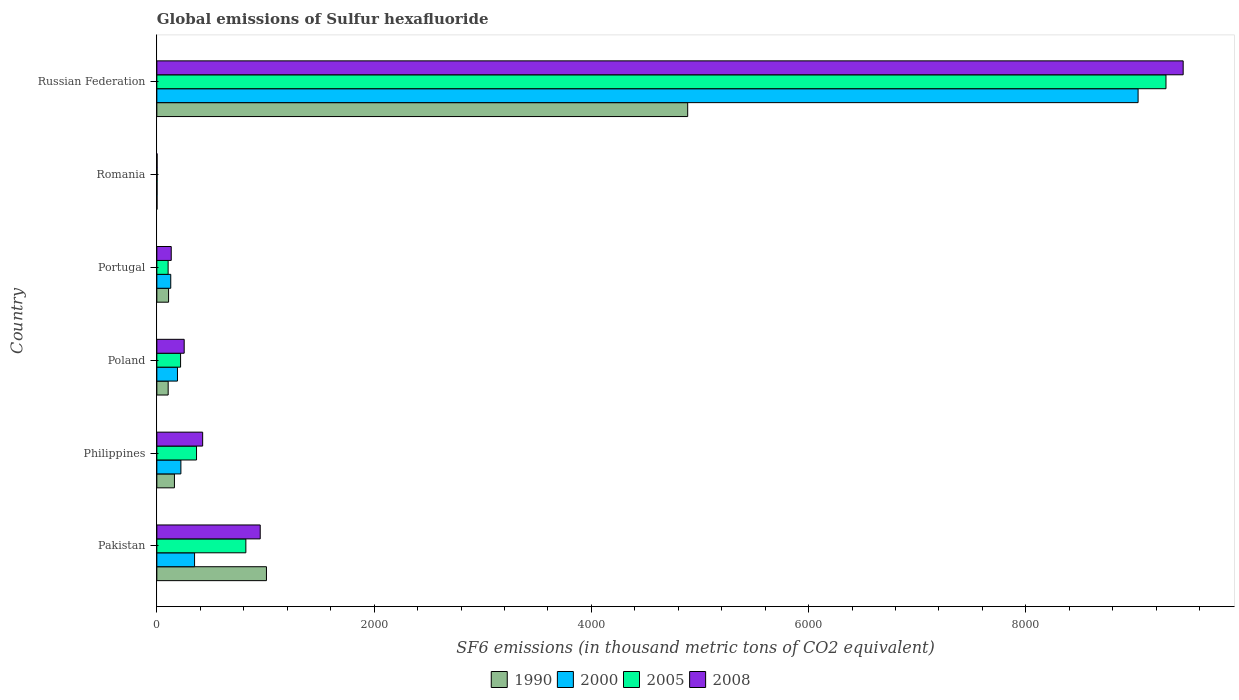How many different coloured bars are there?
Provide a succinct answer. 4. Are the number of bars per tick equal to the number of legend labels?
Your response must be concise. Yes. Are the number of bars on each tick of the Y-axis equal?
Provide a short and direct response. Yes. How many bars are there on the 4th tick from the top?
Your response must be concise. 4. How many bars are there on the 5th tick from the bottom?
Your response must be concise. 4. What is the global emissions of Sulfur hexafluoride in 1990 in Philippines?
Your response must be concise. 161.9. Across all countries, what is the maximum global emissions of Sulfur hexafluoride in 2008?
Ensure brevity in your answer.  9448.2. In which country was the global emissions of Sulfur hexafluoride in 1990 maximum?
Make the answer very short. Russian Federation. In which country was the global emissions of Sulfur hexafluoride in 2000 minimum?
Provide a succinct answer. Romania. What is the total global emissions of Sulfur hexafluoride in 2008 in the graph?
Your answer should be compact. 1.12e+04. What is the difference between the global emissions of Sulfur hexafluoride in 2000 in Pakistan and that in Russian Federation?
Your answer should be compact. -8686. What is the difference between the global emissions of Sulfur hexafluoride in 2008 in Russian Federation and the global emissions of Sulfur hexafluoride in 2005 in Pakistan?
Your answer should be very brief. 8628.8. What is the average global emissions of Sulfur hexafluoride in 2008 per country?
Provide a short and direct response. 1867.98. What is the difference between the global emissions of Sulfur hexafluoride in 2005 and global emissions of Sulfur hexafluoride in 2000 in Russian Federation?
Give a very brief answer. 256.7. In how many countries, is the global emissions of Sulfur hexafluoride in 2008 greater than 8000 thousand metric tons?
Make the answer very short. 1. What is the ratio of the global emissions of Sulfur hexafluoride in 1990 in Portugal to that in Russian Federation?
Offer a terse response. 0.02. Is the global emissions of Sulfur hexafluoride in 1990 in Pakistan less than that in Poland?
Provide a succinct answer. No. What is the difference between the highest and the second highest global emissions of Sulfur hexafluoride in 2005?
Provide a succinct answer. 8470.5. What is the difference between the highest and the lowest global emissions of Sulfur hexafluoride in 2008?
Offer a very short reply. 9445.9. Is the sum of the global emissions of Sulfur hexafluoride in 1990 in Philippines and Portugal greater than the maximum global emissions of Sulfur hexafluoride in 2005 across all countries?
Provide a succinct answer. No. Is it the case that in every country, the sum of the global emissions of Sulfur hexafluoride in 1990 and global emissions of Sulfur hexafluoride in 2008 is greater than the sum of global emissions of Sulfur hexafluoride in 2005 and global emissions of Sulfur hexafluoride in 2000?
Your answer should be very brief. No. What does the 2nd bar from the bottom in Pakistan represents?
Keep it short and to the point. 2000. Is it the case that in every country, the sum of the global emissions of Sulfur hexafluoride in 2008 and global emissions of Sulfur hexafluoride in 1990 is greater than the global emissions of Sulfur hexafluoride in 2000?
Make the answer very short. Yes. How many countries are there in the graph?
Ensure brevity in your answer.  6. What is the difference between two consecutive major ticks on the X-axis?
Offer a terse response. 2000. Does the graph contain any zero values?
Offer a very short reply. No. Does the graph contain grids?
Provide a succinct answer. No. Where does the legend appear in the graph?
Offer a terse response. Bottom center. How many legend labels are there?
Make the answer very short. 4. What is the title of the graph?
Keep it short and to the point. Global emissions of Sulfur hexafluoride. Does "1979" appear as one of the legend labels in the graph?
Provide a short and direct response. No. What is the label or title of the X-axis?
Give a very brief answer. SF6 emissions (in thousand metric tons of CO2 equivalent). What is the SF6 emissions (in thousand metric tons of CO2 equivalent) of 1990 in Pakistan?
Offer a terse response. 1009. What is the SF6 emissions (in thousand metric tons of CO2 equivalent) of 2000 in Pakistan?
Your response must be concise. 347.2. What is the SF6 emissions (in thousand metric tons of CO2 equivalent) in 2005 in Pakistan?
Offer a very short reply. 819.4. What is the SF6 emissions (in thousand metric tons of CO2 equivalent) in 2008 in Pakistan?
Your answer should be compact. 951.6. What is the SF6 emissions (in thousand metric tons of CO2 equivalent) of 1990 in Philippines?
Your answer should be very brief. 161.9. What is the SF6 emissions (in thousand metric tons of CO2 equivalent) of 2000 in Philippines?
Provide a short and direct response. 221.4. What is the SF6 emissions (in thousand metric tons of CO2 equivalent) in 2005 in Philippines?
Keep it short and to the point. 365.3. What is the SF6 emissions (in thousand metric tons of CO2 equivalent) of 2008 in Philippines?
Offer a terse response. 421.7. What is the SF6 emissions (in thousand metric tons of CO2 equivalent) of 1990 in Poland?
Provide a short and direct response. 104.3. What is the SF6 emissions (in thousand metric tons of CO2 equivalent) of 2000 in Poland?
Provide a short and direct response. 189.8. What is the SF6 emissions (in thousand metric tons of CO2 equivalent) of 2005 in Poland?
Ensure brevity in your answer.  218.5. What is the SF6 emissions (in thousand metric tons of CO2 equivalent) in 2008 in Poland?
Offer a terse response. 251.7. What is the SF6 emissions (in thousand metric tons of CO2 equivalent) in 1990 in Portugal?
Keep it short and to the point. 108. What is the SF6 emissions (in thousand metric tons of CO2 equivalent) of 2000 in Portugal?
Provide a succinct answer. 128. What is the SF6 emissions (in thousand metric tons of CO2 equivalent) in 2005 in Portugal?
Provide a short and direct response. 103.8. What is the SF6 emissions (in thousand metric tons of CO2 equivalent) of 2008 in Portugal?
Provide a short and direct response. 132.4. What is the SF6 emissions (in thousand metric tons of CO2 equivalent) in 1990 in Romania?
Give a very brief answer. 1.6. What is the SF6 emissions (in thousand metric tons of CO2 equivalent) in 2008 in Romania?
Offer a very short reply. 2.3. What is the SF6 emissions (in thousand metric tons of CO2 equivalent) in 1990 in Russian Federation?
Offer a very short reply. 4886.8. What is the SF6 emissions (in thousand metric tons of CO2 equivalent) of 2000 in Russian Federation?
Your answer should be very brief. 9033.2. What is the SF6 emissions (in thousand metric tons of CO2 equivalent) of 2005 in Russian Federation?
Make the answer very short. 9289.9. What is the SF6 emissions (in thousand metric tons of CO2 equivalent) of 2008 in Russian Federation?
Give a very brief answer. 9448.2. Across all countries, what is the maximum SF6 emissions (in thousand metric tons of CO2 equivalent) of 1990?
Your answer should be very brief. 4886.8. Across all countries, what is the maximum SF6 emissions (in thousand metric tons of CO2 equivalent) of 2000?
Your answer should be compact. 9033.2. Across all countries, what is the maximum SF6 emissions (in thousand metric tons of CO2 equivalent) of 2005?
Give a very brief answer. 9289.9. Across all countries, what is the maximum SF6 emissions (in thousand metric tons of CO2 equivalent) of 2008?
Keep it short and to the point. 9448.2. Across all countries, what is the minimum SF6 emissions (in thousand metric tons of CO2 equivalent) of 2000?
Provide a short and direct response. 2. Across all countries, what is the minimum SF6 emissions (in thousand metric tons of CO2 equivalent) in 2008?
Provide a succinct answer. 2.3. What is the total SF6 emissions (in thousand metric tons of CO2 equivalent) of 1990 in the graph?
Your response must be concise. 6271.6. What is the total SF6 emissions (in thousand metric tons of CO2 equivalent) of 2000 in the graph?
Your answer should be very brief. 9921.6. What is the total SF6 emissions (in thousand metric tons of CO2 equivalent) of 2005 in the graph?
Ensure brevity in your answer.  1.08e+04. What is the total SF6 emissions (in thousand metric tons of CO2 equivalent) in 2008 in the graph?
Offer a terse response. 1.12e+04. What is the difference between the SF6 emissions (in thousand metric tons of CO2 equivalent) in 1990 in Pakistan and that in Philippines?
Provide a short and direct response. 847.1. What is the difference between the SF6 emissions (in thousand metric tons of CO2 equivalent) in 2000 in Pakistan and that in Philippines?
Your response must be concise. 125.8. What is the difference between the SF6 emissions (in thousand metric tons of CO2 equivalent) of 2005 in Pakistan and that in Philippines?
Your response must be concise. 454.1. What is the difference between the SF6 emissions (in thousand metric tons of CO2 equivalent) in 2008 in Pakistan and that in Philippines?
Give a very brief answer. 529.9. What is the difference between the SF6 emissions (in thousand metric tons of CO2 equivalent) in 1990 in Pakistan and that in Poland?
Your response must be concise. 904.7. What is the difference between the SF6 emissions (in thousand metric tons of CO2 equivalent) of 2000 in Pakistan and that in Poland?
Make the answer very short. 157.4. What is the difference between the SF6 emissions (in thousand metric tons of CO2 equivalent) in 2005 in Pakistan and that in Poland?
Make the answer very short. 600.9. What is the difference between the SF6 emissions (in thousand metric tons of CO2 equivalent) in 2008 in Pakistan and that in Poland?
Keep it short and to the point. 699.9. What is the difference between the SF6 emissions (in thousand metric tons of CO2 equivalent) in 1990 in Pakistan and that in Portugal?
Provide a succinct answer. 901. What is the difference between the SF6 emissions (in thousand metric tons of CO2 equivalent) in 2000 in Pakistan and that in Portugal?
Ensure brevity in your answer.  219.2. What is the difference between the SF6 emissions (in thousand metric tons of CO2 equivalent) of 2005 in Pakistan and that in Portugal?
Offer a terse response. 715.6. What is the difference between the SF6 emissions (in thousand metric tons of CO2 equivalent) in 2008 in Pakistan and that in Portugal?
Give a very brief answer. 819.2. What is the difference between the SF6 emissions (in thousand metric tons of CO2 equivalent) in 1990 in Pakistan and that in Romania?
Offer a terse response. 1007.4. What is the difference between the SF6 emissions (in thousand metric tons of CO2 equivalent) in 2000 in Pakistan and that in Romania?
Offer a very short reply. 345.2. What is the difference between the SF6 emissions (in thousand metric tons of CO2 equivalent) in 2005 in Pakistan and that in Romania?
Ensure brevity in your answer.  817.2. What is the difference between the SF6 emissions (in thousand metric tons of CO2 equivalent) of 2008 in Pakistan and that in Romania?
Offer a terse response. 949.3. What is the difference between the SF6 emissions (in thousand metric tons of CO2 equivalent) in 1990 in Pakistan and that in Russian Federation?
Keep it short and to the point. -3877.8. What is the difference between the SF6 emissions (in thousand metric tons of CO2 equivalent) of 2000 in Pakistan and that in Russian Federation?
Give a very brief answer. -8686. What is the difference between the SF6 emissions (in thousand metric tons of CO2 equivalent) of 2005 in Pakistan and that in Russian Federation?
Offer a very short reply. -8470.5. What is the difference between the SF6 emissions (in thousand metric tons of CO2 equivalent) of 2008 in Pakistan and that in Russian Federation?
Your answer should be very brief. -8496.6. What is the difference between the SF6 emissions (in thousand metric tons of CO2 equivalent) of 1990 in Philippines and that in Poland?
Provide a short and direct response. 57.6. What is the difference between the SF6 emissions (in thousand metric tons of CO2 equivalent) of 2000 in Philippines and that in Poland?
Give a very brief answer. 31.6. What is the difference between the SF6 emissions (in thousand metric tons of CO2 equivalent) in 2005 in Philippines and that in Poland?
Your response must be concise. 146.8. What is the difference between the SF6 emissions (in thousand metric tons of CO2 equivalent) of 2008 in Philippines and that in Poland?
Ensure brevity in your answer.  170. What is the difference between the SF6 emissions (in thousand metric tons of CO2 equivalent) of 1990 in Philippines and that in Portugal?
Ensure brevity in your answer.  53.9. What is the difference between the SF6 emissions (in thousand metric tons of CO2 equivalent) in 2000 in Philippines and that in Portugal?
Your answer should be very brief. 93.4. What is the difference between the SF6 emissions (in thousand metric tons of CO2 equivalent) in 2005 in Philippines and that in Portugal?
Provide a succinct answer. 261.5. What is the difference between the SF6 emissions (in thousand metric tons of CO2 equivalent) of 2008 in Philippines and that in Portugal?
Offer a terse response. 289.3. What is the difference between the SF6 emissions (in thousand metric tons of CO2 equivalent) in 1990 in Philippines and that in Romania?
Your answer should be compact. 160.3. What is the difference between the SF6 emissions (in thousand metric tons of CO2 equivalent) in 2000 in Philippines and that in Romania?
Provide a succinct answer. 219.4. What is the difference between the SF6 emissions (in thousand metric tons of CO2 equivalent) in 2005 in Philippines and that in Romania?
Provide a short and direct response. 363.1. What is the difference between the SF6 emissions (in thousand metric tons of CO2 equivalent) of 2008 in Philippines and that in Romania?
Your response must be concise. 419.4. What is the difference between the SF6 emissions (in thousand metric tons of CO2 equivalent) in 1990 in Philippines and that in Russian Federation?
Your answer should be compact. -4724.9. What is the difference between the SF6 emissions (in thousand metric tons of CO2 equivalent) of 2000 in Philippines and that in Russian Federation?
Your response must be concise. -8811.8. What is the difference between the SF6 emissions (in thousand metric tons of CO2 equivalent) in 2005 in Philippines and that in Russian Federation?
Make the answer very short. -8924.6. What is the difference between the SF6 emissions (in thousand metric tons of CO2 equivalent) of 2008 in Philippines and that in Russian Federation?
Keep it short and to the point. -9026.5. What is the difference between the SF6 emissions (in thousand metric tons of CO2 equivalent) of 1990 in Poland and that in Portugal?
Your response must be concise. -3.7. What is the difference between the SF6 emissions (in thousand metric tons of CO2 equivalent) in 2000 in Poland and that in Portugal?
Offer a very short reply. 61.8. What is the difference between the SF6 emissions (in thousand metric tons of CO2 equivalent) of 2005 in Poland and that in Portugal?
Make the answer very short. 114.7. What is the difference between the SF6 emissions (in thousand metric tons of CO2 equivalent) in 2008 in Poland and that in Portugal?
Ensure brevity in your answer.  119.3. What is the difference between the SF6 emissions (in thousand metric tons of CO2 equivalent) of 1990 in Poland and that in Romania?
Keep it short and to the point. 102.7. What is the difference between the SF6 emissions (in thousand metric tons of CO2 equivalent) of 2000 in Poland and that in Romania?
Your response must be concise. 187.8. What is the difference between the SF6 emissions (in thousand metric tons of CO2 equivalent) in 2005 in Poland and that in Romania?
Provide a short and direct response. 216.3. What is the difference between the SF6 emissions (in thousand metric tons of CO2 equivalent) of 2008 in Poland and that in Romania?
Your response must be concise. 249.4. What is the difference between the SF6 emissions (in thousand metric tons of CO2 equivalent) in 1990 in Poland and that in Russian Federation?
Ensure brevity in your answer.  -4782.5. What is the difference between the SF6 emissions (in thousand metric tons of CO2 equivalent) of 2000 in Poland and that in Russian Federation?
Keep it short and to the point. -8843.4. What is the difference between the SF6 emissions (in thousand metric tons of CO2 equivalent) of 2005 in Poland and that in Russian Federation?
Ensure brevity in your answer.  -9071.4. What is the difference between the SF6 emissions (in thousand metric tons of CO2 equivalent) of 2008 in Poland and that in Russian Federation?
Make the answer very short. -9196.5. What is the difference between the SF6 emissions (in thousand metric tons of CO2 equivalent) in 1990 in Portugal and that in Romania?
Provide a short and direct response. 106.4. What is the difference between the SF6 emissions (in thousand metric tons of CO2 equivalent) in 2000 in Portugal and that in Romania?
Offer a terse response. 126. What is the difference between the SF6 emissions (in thousand metric tons of CO2 equivalent) in 2005 in Portugal and that in Romania?
Your answer should be compact. 101.6. What is the difference between the SF6 emissions (in thousand metric tons of CO2 equivalent) of 2008 in Portugal and that in Romania?
Provide a short and direct response. 130.1. What is the difference between the SF6 emissions (in thousand metric tons of CO2 equivalent) in 1990 in Portugal and that in Russian Federation?
Your response must be concise. -4778.8. What is the difference between the SF6 emissions (in thousand metric tons of CO2 equivalent) of 2000 in Portugal and that in Russian Federation?
Make the answer very short. -8905.2. What is the difference between the SF6 emissions (in thousand metric tons of CO2 equivalent) in 2005 in Portugal and that in Russian Federation?
Offer a terse response. -9186.1. What is the difference between the SF6 emissions (in thousand metric tons of CO2 equivalent) in 2008 in Portugal and that in Russian Federation?
Your answer should be very brief. -9315.8. What is the difference between the SF6 emissions (in thousand metric tons of CO2 equivalent) in 1990 in Romania and that in Russian Federation?
Provide a short and direct response. -4885.2. What is the difference between the SF6 emissions (in thousand metric tons of CO2 equivalent) in 2000 in Romania and that in Russian Federation?
Keep it short and to the point. -9031.2. What is the difference between the SF6 emissions (in thousand metric tons of CO2 equivalent) in 2005 in Romania and that in Russian Federation?
Make the answer very short. -9287.7. What is the difference between the SF6 emissions (in thousand metric tons of CO2 equivalent) of 2008 in Romania and that in Russian Federation?
Ensure brevity in your answer.  -9445.9. What is the difference between the SF6 emissions (in thousand metric tons of CO2 equivalent) in 1990 in Pakistan and the SF6 emissions (in thousand metric tons of CO2 equivalent) in 2000 in Philippines?
Offer a very short reply. 787.6. What is the difference between the SF6 emissions (in thousand metric tons of CO2 equivalent) in 1990 in Pakistan and the SF6 emissions (in thousand metric tons of CO2 equivalent) in 2005 in Philippines?
Offer a very short reply. 643.7. What is the difference between the SF6 emissions (in thousand metric tons of CO2 equivalent) of 1990 in Pakistan and the SF6 emissions (in thousand metric tons of CO2 equivalent) of 2008 in Philippines?
Give a very brief answer. 587.3. What is the difference between the SF6 emissions (in thousand metric tons of CO2 equivalent) of 2000 in Pakistan and the SF6 emissions (in thousand metric tons of CO2 equivalent) of 2005 in Philippines?
Provide a succinct answer. -18.1. What is the difference between the SF6 emissions (in thousand metric tons of CO2 equivalent) of 2000 in Pakistan and the SF6 emissions (in thousand metric tons of CO2 equivalent) of 2008 in Philippines?
Provide a short and direct response. -74.5. What is the difference between the SF6 emissions (in thousand metric tons of CO2 equivalent) in 2005 in Pakistan and the SF6 emissions (in thousand metric tons of CO2 equivalent) in 2008 in Philippines?
Offer a very short reply. 397.7. What is the difference between the SF6 emissions (in thousand metric tons of CO2 equivalent) of 1990 in Pakistan and the SF6 emissions (in thousand metric tons of CO2 equivalent) of 2000 in Poland?
Provide a short and direct response. 819.2. What is the difference between the SF6 emissions (in thousand metric tons of CO2 equivalent) in 1990 in Pakistan and the SF6 emissions (in thousand metric tons of CO2 equivalent) in 2005 in Poland?
Give a very brief answer. 790.5. What is the difference between the SF6 emissions (in thousand metric tons of CO2 equivalent) in 1990 in Pakistan and the SF6 emissions (in thousand metric tons of CO2 equivalent) in 2008 in Poland?
Give a very brief answer. 757.3. What is the difference between the SF6 emissions (in thousand metric tons of CO2 equivalent) of 2000 in Pakistan and the SF6 emissions (in thousand metric tons of CO2 equivalent) of 2005 in Poland?
Ensure brevity in your answer.  128.7. What is the difference between the SF6 emissions (in thousand metric tons of CO2 equivalent) in 2000 in Pakistan and the SF6 emissions (in thousand metric tons of CO2 equivalent) in 2008 in Poland?
Keep it short and to the point. 95.5. What is the difference between the SF6 emissions (in thousand metric tons of CO2 equivalent) in 2005 in Pakistan and the SF6 emissions (in thousand metric tons of CO2 equivalent) in 2008 in Poland?
Your answer should be compact. 567.7. What is the difference between the SF6 emissions (in thousand metric tons of CO2 equivalent) of 1990 in Pakistan and the SF6 emissions (in thousand metric tons of CO2 equivalent) of 2000 in Portugal?
Offer a terse response. 881. What is the difference between the SF6 emissions (in thousand metric tons of CO2 equivalent) of 1990 in Pakistan and the SF6 emissions (in thousand metric tons of CO2 equivalent) of 2005 in Portugal?
Provide a succinct answer. 905.2. What is the difference between the SF6 emissions (in thousand metric tons of CO2 equivalent) in 1990 in Pakistan and the SF6 emissions (in thousand metric tons of CO2 equivalent) in 2008 in Portugal?
Your response must be concise. 876.6. What is the difference between the SF6 emissions (in thousand metric tons of CO2 equivalent) in 2000 in Pakistan and the SF6 emissions (in thousand metric tons of CO2 equivalent) in 2005 in Portugal?
Your response must be concise. 243.4. What is the difference between the SF6 emissions (in thousand metric tons of CO2 equivalent) of 2000 in Pakistan and the SF6 emissions (in thousand metric tons of CO2 equivalent) of 2008 in Portugal?
Offer a terse response. 214.8. What is the difference between the SF6 emissions (in thousand metric tons of CO2 equivalent) of 2005 in Pakistan and the SF6 emissions (in thousand metric tons of CO2 equivalent) of 2008 in Portugal?
Offer a terse response. 687. What is the difference between the SF6 emissions (in thousand metric tons of CO2 equivalent) of 1990 in Pakistan and the SF6 emissions (in thousand metric tons of CO2 equivalent) of 2000 in Romania?
Give a very brief answer. 1007. What is the difference between the SF6 emissions (in thousand metric tons of CO2 equivalent) in 1990 in Pakistan and the SF6 emissions (in thousand metric tons of CO2 equivalent) in 2005 in Romania?
Keep it short and to the point. 1006.8. What is the difference between the SF6 emissions (in thousand metric tons of CO2 equivalent) of 1990 in Pakistan and the SF6 emissions (in thousand metric tons of CO2 equivalent) of 2008 in Romania?
Offer a terse response. 1006.7. What is the difference between the SF6 emissions (in thousand metric tons of CO2 equivalent) in 2000 in Pakistan and the SF6 emissions (in thousand metric tons of CO2 equivalent) in 2005 in Romania?
Your response must be concise. 345. What is the difference between the SF6 emissions (in thousand metric tons of CO2 equivalent) of 2000 in Pakistan and the SF6 emissions (in thousand metric tons of CO2 equivalent) of 2008 in Romania?
Provide a short and direct response. 344.9. What is the difference between the SF6 emissions (in thousand metric tons of CO2 equivalent) in 2005 in Pakistan and the SF6 emissions (in thousand metric tons of CO2 equivalent) in 2008 in Romania?
Keep it short and to the point. 817.1. What is the difference between the SF6 emissions (in thousand metric tons of CO2 equivalent) in 1990 in Pakistan and the SF6 emissions (in thousand metric tons of CO2 equivalent) in 2000 in Russian Federation?
Give a very brief answer. -8024.2. What is the difference between the SF6 emissions (in thousand metric tons of CO2 equivalent) in 1990 in Pakistan and the SF6 emissions (in thousand metric tons of CO2 equivalent) in 2005 in Russian Federation?
Give a very brief answer. -8280.9. What is the difference between the SF6 emissions (in thousand metric tons of CO2 equivalent) in 1990 in Pakistan and the SF6 emissions (in thousand metric tons of CO2 equivalent) in 2008 in Russian Federation?
Keep it short and to the point. -8439.2. What is the difference between the SF6 emissions (in thousand metric tons of CO2 equivalent) in 2000 in Pakistan and the SF6 emissions (in thousand metric tons of CO2 equivalent) in 2005 in Russian Federation?
Make the answer very short. -8942.7. What is the difference between the SF6 emissions (in thousand metric tons of CO2 equivalent) of 2000 in Pakistan and the SF6 emissions (in thousand metric tons of CO2 equivalent) of 2008 in Russian Federation?
Provide a succinct answer. -9101. What is the difference between the SF6 emissions (in thousand metric tons of CO2 equivalent) in 2005 in Pakistan and the SF6 emissions (in thousand metric tons of CO2 equivalent) in 2008 in Russian Federation?
Offer a very short reply. -8628.8. What is the difference between the SF6 emissions (in thousand metric tons of CO2 equivalent) of 1990 in Philippines and the SF6 emissions (in thousand metric tons of CO2 equivalent) of 2000 in Poland?
Offer a terse response. -27.9. What is the difference between the SF6 emissions (in thousand metric tons of CO2 equivalent) in 1990 in Philippines and the SF6 emissions (in thousand metric tons of CO2 equivalent) in 2005 in Poland?
Your answer should be very brief. -56.6. What is the difference between the SF6 emissions (in thousand metric tons of CO2 equivalent) in 1990 in Philippines and the SF6 emissions (in thousand metric tons of CO2 equivalent) in 2008 in Poland?
Your response must be concise. -89.8. What is the difference between the SF6 emissions (in thousand metric tons of CO2 equivalent) of 2000 in Philippines and the SF6 emissions (in thousand metric tons of CO2 equivalent) of 2008 in Poland?
Your response must be concise. -30.3. What is the difference between the SF6 emissions (in thousand metric tons of CO2 equivalent) in 2005 in Philippines and the SF6 emissions (in thousand metric tons of CO2 equivalent) in 2008 in Poland?
Ensure brevity in your answer.  113.6. What is the difference between the SF6 emissions (in thousand metric tons of CO2 equivalent) in 1990 in Philippines and the SF6 emissions (in thousand metric tons of CO2 equivalent) in 2000 in Portugal?
Give a very brief answer. 33.9. What is the difference between the SF6 emissions (in thousand metric tons of CO2 equivalent) in 1990 in Philippines and the SF6 emissions (in thousand metric tons of CO2 equivalent) in 2005 in Portugal?
Provide a succinct answer. 58.1. What is the difference between the SF6 emissions (in thousand metric tons of CO2 equivalent) in 1990 in Philippines and the SF6 emissions (in thousand metric tons of CO2 equivalent) in 2008 in Portugal?
Keep it short and to the point. 29.5. What is the difference between the SF6 emissions (in thousand metric tons of CO2 equivalent) of 2000 in Philippines and the SF6 emissions (in thousand metric tons of CO2 equivalent) of 2005 in Portugal?
Your response must be concise. 117.6. What is the difference between the SF6 emissions (in thousand metric tons of CO2 equivalent) in 2000 in Philippines and the SF6 emissions (in thousand metric tons of CO2 equivalent) in 2008 in Portugal?
Make the answer very short. 89. What is the difference between the SF6 emissions (in thousand metric tons of CO2 equivalent) of 2005 in Philippines and the SF6 emissions (in thousand metric tons of CO2 equivalent) of 2008 in Portugal?
Ensure brevity in your answer.  232.9. What is the difference between the SF6 emissions (in thousand metric tons of CO2 equivalent) in 1990 in Philippines and the SF6 emissions (in thousand metric tons of CO2 equivalent) in 2000 in Romania?
Your response must be concise. 159.9. What is the difference between the SF6 emissions (in thousand metric tons of CO2 equivalent) in 1990 in Philippines and the SF6 emissions (in thousand metric tons of CO2 equivalent) in 2005 in Romania?
Provide a succinct answer. 159.7. What is the difference between the SF6 emissions (in thousand metric tons of CO2 equivalent) of 1990 in Philippines and the SF6 emissions (in thousand metric tons of CO2 equivalent) of 2008 in Romania?
Keep it short and to the point. 159.6. What is the difference between the SF6 emissions (in thousand metric tons of CO2 equivalent) in 2000 in Philippines and the SF6 emissions (in thousand metric tons of CO2 equivalent) in 2005 in Romania?
Provide a succinct answer. 219.2. What is the difference between the SF6 emissions (in thousand metric tons of CO2 equivalent) in 2000 in Philippines and the SF6 emissions (in thousand metric tons of CO2 equivalent) in 2008 in Romania?
Your answer should be very brief. 219.1. What is the difference between the SF6 emissions (in thousand metric tons of CO2 equivalent) in 2005 in Philippines and the SF6 emissions (in thousand metric tons of CO2 equivalent) in 2008 in Romania?
Ensure brevity in your answer.  363. What is the difference between the SF6 emissions (in thousand metric tons of CO2 equivalent) of 1990 in Philippines and the SF6 emissions (in thousand metric tons of CO2 equivalent) of 2000 in Russian Federation?
Your answer should be compact. -8871.3. What is the difference between the SF6 emissions (in thousand metric tons of CO2 equivalent) of 1990 in Philippines and the SF6 emissions (in thousand metric tons of CO2 equivalent) of 2005 in Russian Federation?
Provide a short and direct response. -9128. What is the difference between the SF6 emissions (in thousand metric tons of CO2 equivalent) in 1990 in Philippines and the SF6 emissions (in thousand metric tons of CO2 equivalent) in 2008 in Russian Federation?
Provide a short and direct response. -9286.3. What is the difference between the SF6 emissions (in thousand metric tons of CO2 equivalent) in 2000 in Philippines and the SF6 emissions (in thousand metric tons of CO2 equivalent) in 2005 in Russian Federation?
Your answer should be compact. -9068.5. What is the difference between the SF6 emissions (in thousand metric tons of CO2 equivalent) of 2000 in Philippines and the SF6 emissions (in thousand metric tons of CO2 equivalent) of 2008 in Russian Federation?
Your response must be concise. -9226.8. What is the difference between the SF6 emissions (in thousand metric tons of CO2 equivalent) in 2005 in Philippines and the SF6 emissions (in thousand metric tons of CO2 equivalent) in 2008 in Russian Federation?
Your response must be concise. -9082.9. What is the difference between the SF6 emissions (in thousand metric tons of CO2 equivalent) of 1990 in Poland and the SF6 emissions (in thousand metric tons of CO2 equivalent) of 2000 in Portugal?
Ensure brevity in your answer.  -23.7. What is the difference between the SF6 emissions (in thousand metric tons of CO2 equivalent) of 1990 in Poland and the SF6 emissions (in thousand metric tons of CO2 equivalent) of 2005 in Portugal?
Provide a short and direct response. 0.5. What is the difference between the SF6 emissions (in thousand metric tons of CO2 equivalent) in 1990 in Poland and the SF6 emissions (in thousand metric tons of CO2 equivalent) in 2008 in Portugal?
Provide a short and direct response. -28.1. What is the difference between the SF6 emissions (in thousand metric tons of CO2 equivalent) of 2000 in Poland and the SF6 emissions (in thousand metric tons of CO2 equivalent) of 2008 in Portugal?
Offer a terse response. 57.4. What is the difference between the SF6 emissions (in thousand metric tons of CO2 equivalent) in 2005 in Poland and the SF6 emissions (in thousand metric tons of CO2 equivalent) in 2008 in Portugal?
Offer a very short reply. 86.1. What is the difference between the SF6 emissions (in thousand metric tons of CO2 equivalent) in 1990 in Poland and the SF6 emissions (in thousand metric tons of CO2 equivalent) in 2000 in Romania?
Provide a short and direct response. 102.3. What is the difference between the SF6 emissions (in thousand metric tons of CO2 equivalent) of 1990 in Poland and the SF6 emissions (in thousand metric tons of CO2 equivalent) of 2005 in Romania?
Your answer should be compact. 102.1. What is the difference between the SF6 emissions (in thousand metric tons of CO2 equivalent) of 1990 in Poland and the SF6 emissions (in thousand metric tons of CO2 equivalent) of 2008 in Romania?
Keep it short and to the point. 102. What is the difference between the SF6 emissions (in thousand metric tons of CO2 equivalent) in 2000 in Poland and the SF6 emissions (in thousand metric tons of CO2 equivalent) in 2005 in Romania?
Your answer should be very brief. 187.6. What is the difference between the SF6 emissions (in thousand metric tons of CO2 equivalent) in 2000 in Poland and the SF6 emissions (in thousand metric tons of CO2 equivalent) in 2008 in Romania?
Your response must be concise. 187.5. What is the difference between the SF6 emissions (in thousand metric tons of CO2 equivalent) of 2005 in Poland and the SF6 emissions (in thousand metric tons of CO2 equivalent) of 2008 in Romania?
Give a very brief answer. 216.2. What is the difference between the SF6 emissions (in thousand metric tons of CO2 equivalent) in 1990 in Poland and the SF6 emissions (in thousand metric tons of CO2 equivalent) in 2000 in Russian Federation?
Make the answer very short. -8928.9. What is the difference between the SF6 emissions (in thousand metric tons of CO2 equivalent) of 1990 in Poland and the SF6 emissions (in thousand metric tons of CO2 equivalent) of 2005 in Russian Federation?
Provide a short and direct response. -9185.6. What is the difference between the SF6 emissions (in thousand metric tons of CO2 equivalent) in 1990 in Poland and the SF6 emissions (in thousand metric tons of CO2 equivalent) in 2008 in Russian Federation?
Provide a short and direct response. -9343.9. What is the difference between the SF6 emissions (in thousand metric tons of CO2 equivalent) in 2000 in Poland and the SF6 emissions (in thousand metric tons of CO2 equivalent) in 2005 in Russian Federation?
Your response must be concise. -9100.1. What is the difference between the SF6 emissions (in thousand metric tons of CO2 equivalent) in 2000 in Poland and the SF6 emissions (in thousand metric tons of CO2 equivalent) in 2008 in Russian Federation?
Your answer should be compact. -9258.4. What is the difference between the SF6 emissions (in thousand metric tons of CO2 equivalent) of 2005 in Poland and the SF6 emissions (in thousand metric tons of CO2 equivalent) of 2008 in Russian Federation?
Give a very brief answer. -9229.7. What is the difference between the SF6 emissions (in thousand metric tons of CO2 equivalent) in 1990 in Portugal and the SF6 emissions (in thousand metric tons of CO2 equivalent) in 2000 in Romania?
Offer a very short reply. 106. What is the difference between the SF6 emissions (in thousand metric tons of CO2 equivalent) of 1990 in Portugal and the SF6 emissions (in thousand metric tons of CO2 equivalent) of 2005 in Romania?
Keep it short and to the point. 105.8. What is the difference between the SF6 emissions (in thousand metric tons of CO2 equivalent) in 1990 in Portugal and the SF6 emissions (in thousand metric tons of CO2 equivalent) in 2008 in Romania?
Keep it short and to the point. 105.7. What is the difference between the SF6 emissions (in thousand metric tons of CO2 equivalent) of 2000 in Portugal and the SF6 emissions (in thousand metric tons of CO2 equivalent) of 2005 in Romania?
Your answer should be compact. 125.8. What is the difference between the SF6 emissions (in thousand metric tons of CO2 equivalent) in 2000 in Portugal and the SF6 emissions (in thousand metric tons of CO2 equivalent) in 2008 in Romania?
Give a very brief answer. 125.7. What is the difference between the SF6 emissions (in thousand metric tons of CO2 equivalent) of 2005 in Portugal and the SF6 emissions (in thousand metric tons of CO2 equivalent) of 2008 in Romania?
Your answer should be very brief. 101.5. What is the difference between the SF6 emissions (in thousand metric tons of CO2 equivalent) of 1990 in Portugal and the SF6 emissions (in thousand metric tons of CO2 equivalent) of 2000 in Russian Federation?
Keep it short and to the point. -8925.2. What is the difference between the SF6 emissions (in thousand metric tons of CO2 equivalent) of 1990 in Portugal and the SF6 emissions (in thousand metric tons of CO2 equivalent) of 2005 in Russian Federation?
Your answer should be very brief. -9181.9. What is the difference between the SF6 emissions (in thousand metric tons of CO2 equivalent) of 1990 in Portugal and the SF6 emissions (in thousand metric tons of CO2 equivalent) of 2008 in Russian Federation?
Give a very brief answer. -9340.2. What is the difference between the SF6 emissions (in thousand metric tons of CO2 equivalent) of 2000 in Portugal and the SF6 emissions (in thousand metric tons of CO2 equivalent) of 2005 in Russian Federation?
Offer a very short reply. -9161.9. What is the difference between the SF6 emissions (in thousand metric tons of CO2 equivalent) in 2000 in Portugal and the SF6 emissions (in thousand metric tons of CO2 equivalent) in 2008 in Russian Federation?
Offer a terse response. -9320.2. What is the difference between the SF6 emissions (in thousand metric tons of CO2 equivalent) of 2005 in Portugal and the SF6 emissions (in thousand metric tons of CO2 equivalent) of 2008 in Russian Federation?
Offer a very short reply. -9344.4. What is the difference between the SF6 emissions (in thousand metric tons of CO2 equivalent) in 1990 in Romania and the SF6 emissions (in thousand metric tons of CO2 equivalent) in 2000 in Russian Federation?
Provide a short and direct response. -9031.6. What is the difference between the SF6 emissions (in thousand metric tons of CO2 equivalent) in 1990 in Romania and the SF6 emissions (in thousand metric tons of CO2 equivalent) in 2005 in Russian Federation?
Give a very brief answer. -9288.3. What is the difference between the SF6 emissions (in thousand metric tons of CO2 equivalent) of 1990 in Romania and the SF6 emissions (in thousand metric tons of CO2 equivalent) of 2008 in Russian Federation?
Make the answer very short. -9446.6. What is the difference between the SF6 emissions (in thousand metric tons of CO2 equivalent) of 2000 in Romania and the SF6 emissions (in thousand metric tons of CO2 equivalent) of 2005 in Russian Federation?
Your response must be concise. -9287.9. What is the difference between the SF6 emissions (in thousand metric tons of CO2 equivalent) in 2000 in Romania and the SF6 emissions (in thousand metric tons of CO2 equivalent) in 2008 in Russian Federation?
Give a very brief answer. -9446.2. What is the difference between the SF6 emissions (in thousand metric tons of CO2 equivalent) of 2005 in Romania and the SF6 emissions (in thousand metric tons of CO2 equivalent) of 2008 in Russian Federation?
Ensure brevity in your answer.  -9446. What is the average SF6 emissions (in thousand metric tons of CO2 equivalent) in 1990 per country?
Your response must be concise. 1045.27. What is the average SF6 emissions (in thousand metric tons of CO2 equivalent) in 2000 per country?
Keep it short and to the point. 1653.6. What is the average SF6 emissions (in thousand metric tons of CO2 equivalent) in 2005 per country?
Offer a very short reply. 1799.85. What is the average SF6 emissions (in thousand metric tons of CO2 equivalent) in 2008 per country?
Offer a very short reply. 1867.98. What is the difference between the SF6 emissions (in thousand metric tons of CO2 equivalent) of 1990 and SF6 emissions (in thousand metric tons of CO2 equivalent) of 2000 in Pakistan?
Give a very brief answer. 661.8. What is the difference between the SF6 emissions (in thousand metric tons of CO2 equivalent) of 1990 and SF6 emissions (in thousand metric tons of CO2 equivalent) of 2005 in Pakistan?
Make the answer very short. 189.6. What is the difference between the SF6 emissions (in thousand metric tons of CO2 equivalent) of 1990 and SF6 emissions (in thousand metric tons of CO2 equivalent) of 2008 in Pakistan?
Provide a short and direct response. 57.4. What is the difference between the SF6 emissions (in thousand metric tons of CO2 equivalent) in 2000 and SF6 emissions (in thousand metric tons of CO2 equivalent) in 2005 in Pakistan?
Ensure brevity in your answer.  -472.2. What is the difference between the SF6 emissions (in thousand metric tons of CO2 equivalent) of 2000 and SF6 emissions (in thousand metric tons of CO2 equivalent) of 2008 in Pakistan?
Offer a terse response. -604.4. What is the difference between the SF6 emissions (in thousand metric tons of CO2 equivalent) in 2005 and SF6 emissions (in thousand metric tons of CO2 equivalent) in 2008 in Pakistan?
Give a very brief answer. -132.2. What is the difference between the SF6 emissions (in thousand metric tons of CO2 equivalent) in 1990 and SF6 emissions (in thousand metric tons of CO2 equivalent) in 2000 in Philippines?
Your answer should be very brief. -59.5. What is the difference between the SF6 emissions (in thousand metric tons of CO2 equivalent) of 1990 and SF6 emissions (in thousand metric tons of CO2 equivalent) of 2005 in Philippines?
Provide a short and direct response. -203.4. What is the difference between the SF6 emissions (in thousand metric tons of CO2 equivalent) of 1990 and SF6 emissions (in thousand metric tons of CO2 equivalent) of 2008 in Philippines?
Offer a very short reply. -259.8. What is the difference between the SF6 emissions (in thousand metric tons of CO2 equivalent) of 2000 and SF6 emissions (in thousand metric tons of CO2 equivalent) of 2005 in Philippines?
Ensure brevity in your answer.  -143.9. What is the difference between the SF6 emissions (in thousand metric tons of CO2 equivalent) of 2000 and SF6 emissions (in thousand metric tons of CO2 equivalent) of 2008 in Philippines?
Offer a very short reply. -200.3. What is the difference between the SF6 emissions (in thousand metric tons of CO2 equivalent) of 2005 and SF6 emissions (in thousand metric tons of CO2 equivalent) of 2008 in Philippines?
Provide a succinct answer. -56.4. What is the difference between the SF6 emissions (in thousand metric tons of CO2 equivalent) in 1990 and SF6 emissions (in thousand metric tons of CO2 equivalent) in 2000 in Poland?
Provide a succinct answer. -85.5. What is the difference between the SF6 emissions (in thousand metric tons of CO2 equivalent) in 1990 and SF6 emissions (in thousand metric tons of CO2 equivalent) in 2005 in Poland?
Make the answer very short. -114.2. What is the difference between the SF6 emissions (in thousand metric tons of CO2 equivalent) in 1990 and SF6 emissions (in thousand metric tons of CO2 equivalent) in 2008 in Poland?
Your answer should be compact. -147.4. What is the difference between the SF6 emissions (in thousand metric tons of CO2 equivalent) in 2000 and SF6 emissions (in thousand metric tons of CO2 equivalent) in 2005 in Poland?
Your answer should be very brief. -28.7. What is the difference between the SF6 emissions (in thousand metric tons of CO2 equivalent) in 2000 and SF6 emissions (in thousand metric tons of CO2 equivalent) in 2008 in Poland?
Keep it short and to the point. -61.9. What is the difference between the SF6 emissions (in thousand metric tons of CO2 equivalent) in 2005 and SF6 emissions (in thousand metric tons of CO2 equivalent) in 2008 in Poland?
Offer a terse response. -33.2. What is the difference between the SF6 emissions (in thousand metric tons of CO2 equivalent) of 1990 and SF6 emissions (in thousand metric tons of CO2 equivalent) of 2000 in Portugal?
Make the answer very short. -20. What is the difference between the SF6 emissions (in thousand metric tons of CO2 equivalent) of 1990 and SF6 emissions (in thousand metric tons of CO2 equivalent) of 2005 in Portugal?
Provide a short and direct response. 4.2. What is the difference between the SF6 emissions (in thousand metric tons of CO2 equivalent) of 1990 and SF6 emissions (in thousand metric tons of CO2 equivalent) of 2008 in Portugal?
Keep it short and to the point. -24.4. What is the difference between the SF6 emissions (in thousand metric tons of CO2 equivalent) of 2000 and SF6 emissions (in thousand metric tons of CO2 equivalent) of 2005 in Portugal?
Your response must be concise. 24.2. What is the difference between the SF6 emissions (in thousand metric tons of CO2 equivalent) in 2005 and SF6 emissions (in thousand metric tons of CO2 equivalent) in 2008 in Portugal?
Ensure brevity in your answer.  -28.6. What is the difference between the SF6 emissions (in thousand metric tons of CO2 equivalent) in 1990 and SF6 emissions (in thousand metric tons of CO2 equivalent) in 2000 in Romania?
Offer a very short reply. -0.4. What is the difference between the SF6 emissions (in thousand metric tons of CO2 equivalent) in 1990 and SF6 emissions (in thousand metric tons of CO2 equivalent) in 2005 in Romania?
Your answer should be compact. -0.6. What is the difference between the SF6 emissions (in thousand metric tons of CO2 equivalent) in 2000 and SF6 emissions (in thousand metric tons of CO2 equivalent) in 2008 in Romania?
Your answer should be compact. -0.3. What is the difference between the SF6 emissions (in thousand metric tons of CO2 equivalent) in 1990 and SF6 emissions (in thousand metric tons of CO2 equivalent) in 2000 in Russian Federation?
Your answer should be very brief. -4146.4. What is the difference between the SF6 emissions (in thousand metric tons of CO2 equivalent) in 1990 and SF6 emissions (in thousand metric tons of CO2 equivalent) in 2005 in Russian Federation?
Give a very brief answer. -4403.1. What is the difference between the SF6 emissions (in thousand metric tons of CO2 equivalent) of 1990 and SF6 emissions (in thousand metric tons of CO2 equivalent) of 2008 in Russian Federation?
Provide a short and direct response. -4561.4. What is the difference between the SF6 emissions (in thousand metric tons of CO2 equivalent) in 2000 and SF6 emissions (in thousand metric tons of CO2 equivalent) in 2005 in Russian Federation?
Offer a very short reply. -256.7. What is the difference between the SF6 emissions (in thousand metric tons of CO2 equivalent) of 2000 and SF6 emissions (in thousand metric tons of CO2 equivalent) of 2008 in Russian Federation?
Make the answer very short. -415. What is the difference between the SF6 emissions (in thousand metric tons of CO2 equivalent) of 2005 and SF6 emissions (in thousand metric tons of CO2 equivalent) of 2008 in Russian Federation?
Offer a terse response. -158.3. What is the ratio of the SF6 emissions (in thousand metric tons of CO2 equivalent) of 1990 in Pakistan to that in Philippines?
Offer a very short reply. 6.23. What is the ratio of the SF6 emissions (in thousand metric tons of CO2 equivalent) of 2000 in Pakistan to that in Philippines?
Provide a short and direct response. 1.57. What is the ratio of the SF6 emissions (in thousand metric tons of CO2 equivalent) of 2005 in Pakistan to that in Philippines?
Your response must be concise. 2.24. What is the ratio of the SF6 emissions (in thousand metric tons of CO2 equivalent) in 2008 in Pakistan to that in Philippines?
Provide a short and direct response. 2.26. What is the ratio of the SF6 emissions (in thousand metric tons of CO2 equivalent) of 1990 in Pakistan to that in Poland?
Provide a succinct answer. 9.67. What is the ratio of the SF6 emissions (in thousand metric tons of CO2 equivalent) of 2000 in Pakistan to that in Poland?
Ensure brevity in your answer.  1.83. What is the ratio of the SF6 emissions (in thousand metric tons of CO2 equivalent) in 2005 in Pakistan to that in Poland?
Your answer should be very brief. 3.75. What is the ratio of the SF6 emissions (in thousand metric tons of CO2 equivalent) in 2008 in Pakistan to that in Poland?
Keep it short and to the point. 3.78. What is the ratio of the SF6 emissions (in thousand metric tons of CO2 equivalent) of 1990 in Pakistan to that in Portugal?
Provide a succinct answer. 9.34. What is the ratio of the SF6 emissions (in thousand metric tons of CO2 equivalent) in 2000 in Pakistan to that in Portugal?
Provide a short and direct response. 2.71. What is the ratio of the SF6 emissions (in thousand metric tons of CO2 equivalent) in 2005 in Pakistan to that in Portugal?
Offer a very short reply. 7.89. What is the ratio of the SF6 emissions (in thousand metric tons of CO2 equivalent) of 2008 in Pakistan to that in Portugal?
Offer a terse response. 7.19. What is the ratio of the SF6 emissions (in thousand metric tons of CO2 equivalent) in 1990 in Pakistan to that in Romania?
Provide a short and direct response. 630.62. What is the ratio of the SF6 emissions (in thousand metric tons of CO2 equivalent) of 2000 in Pakistan to that in Romania?
Offer a very short reply. 173.6. What is the ratio of the SF6 emissions (in thousand metric tons of CO2 equivalent) of 2005 in Pakistan to that in Romania?
Provide a short and direct response. 372.45. What is the ratio of the SF6 emissions (in thousand metric tons of CO2 equivalent) in 2008 in Pakistan to that in Romania?
Ensure brevity in your answer.  413.74. What is the ratio of the SF6 emissions (in thousand metric tons of CO2 equivalent) of 1990 in Pakistan to that in Russian Federation?
Your answer should be very brief. 0.21. What is the ratio of the SF6 emissions (in thousand metric tons of CO2 equivalent) of 2000 in Pakistan to that in Russian Federation?
Make the answer very short. 0.04. What is the ratio of the SF6 emissions (in thousand metric tons of CO2 equivalent) of 2005 in Pakistan to that in Russian Federation?
Provide a short and direct response. 0.09. What is the ratio of the SF6 emissions (in thousand metric tons of CO2 equivalent) in 2008 in Pakistan to that in Russian Federation?
Give a very brief answer. 0.1. What is the ratio of the SF6 emissions (in thousand metric tons of CO2 equivalent) of 1990 in Philippines to that in Poland?
Give a very brief answer. 1.55. What is the ratio of the SF6 emissions (in thousand metric tons of CO2 equivalent) of 2000 in Philippines to that in Poland?
Keep it short and to the point. 1.17. What is the ratio of the SF6 emissions (in thousand metric tons of CO2 equivalent) of 2005 in Philippines to that in Poland?
Ensure brevity in your answer.  1.67. What is the ratio of the SF6 emissions (in thousand metric tons of CO2 equivalent) of 2008 in Philippines to that in Poland?
Your answer should be very brief. 1.68. What is the ratio of the SF6 emissions (in thousand metric tons of CO2 equivalent) of 1990 in Philippines to that in Portugal?
Give a very brief answer. 1.5. What is the ratio of the SF6 emissions (in thousand metric tons of CO2 equivalent) of 2000 in Philippines to that in Portugal?
Offer a terse response. 1.73. What is the ratio of the SF6 emissions (in thousand metric tons of CO2 equivalent) of 2005 in Philippines to that in Portugal?
Give a very brief answer. 3.52. What is the ratio of the SF6 emissions (in thousand metric tons of CO2 equivalent) in 2008 in Philippines to that in Portugal?
Your response must be concise. 3.19. What is the ratio of the SF6 emissions (in thousand metric tons of CO2 equivalent) in 1990 in Philippines to that in Romania?
Your answer should be compact. 101.19. What is the ratio of the SF6 emissions (in thousand metric tons of CO2 equivalent) in 2000 in Philippines to that in Romania?
Offer a very short reply. 110.7. What is the ratio of the SF6 emissions (in thousand metric tons of CO2 equivalent) in 2005 in Philippines to that in Romania?
Provide a succinct answer. 166.05. What is the ratio of the SF6 emissions (in thousand metric tons of CO2 equivalent) in 2008 in Philippines to that in Romania?
Your response must be concise. 183.35. What is the ratio of the SF6 emissions (in thousand metric tons of CO2 equivalent) in 1990 in Philippines to that in Russian Federation?
Offer a very short reply. 0.03. What is the ratio of the SF6 emissions (in thousand metric tons of CO2 equivalent) in 2000 in Philippines to that in Russian Federation?
Offer a very short reply. 0.02. What is the ratio of the SF6 emissions (in thousand metric tons of CO2 equivalent) of 2005 in Philippines to that in Russian Federation?
Your answer should be very brief. 0.04. What is the ratio of the SF6 emissions (in thousand metric tons of CO2 equivalent) of 2008 in Philippines to that in Russian Federation?
Keep it short and to the point. 0.04. What is the ratio of the SF6 emissions (in thousand metric tons of CO2 equivalent) of 1990 in Poland to that in Portugal?
Offer a very short reply. 0.97. What is the ratio of the SF6 emissions (in thousand metric tons of CO2 equivalent) in 2000 in Poland to that in Portugal?
Give a very brief answer. 1.48. What is the ratio of the SF6 emissions (in thousand metric tons of CO2 equivalent) in 2005 in Poland to that in Portugal?
Provide a short and direct response. 2.1. What is the ratio of the SF6 emissions (in thousand metric tons of CO2 equivalent) in 2008 in Poland to that in Portugal?
Give a very brief answer. 1.9. What is the ratio of the SF6 emissions (in thousand metric tons of CO2 equivalent) of 1990 in Poland to that in Romania?
Offer a terse response. 65.19. What is the ratio of the SF6 emissions (in thousand metric tons of CO2 equivalent) in 2000 in Poland to that in Romania?
Your answer should be compact. 94.9. What is the ratio of the SF6 emissions (in thousand metric tons of CO2 equivalent) of 2005 in Poland to that in Romania?
Give a very brief answer. 99.32. What is the ratio of the SF6 emissions (in thousand metric tons of CO2 equivalent) in 2008 in Poland to that in Romania?
Your answer should be compact. 109.43. What is the ratio of the SF6 emissions (in thousand metric tons of CO2 equivalent) of 1990 in Poland to that in Russian Federation?
Your answer should be compact. 0.02. What is the ratio of the SF6 emissions (in thousand metric tons of CO2 equivalent) in 2000 in Poland to that in Russian Federation?
Ensure brevity in your answer.  0.02. What is the ratio of the SF6 emissions (in thousand metric tons of CO2 equivalent) of 2005 in Poland to that in Russian Federation?
Keep it short and to the point. 0.02. What is the ratio of the SF6 emissions (in thousand metric tons of CO2 equivalent) of 2008 in Poland to that in Russian Federation?
Your answer should be very brief. 0.03. What is the ratio of the SF6 emissions (in thousand metric tons of CO2 equivalent) of 1990 in Portugal to that in Romania?
Your response must be concise. 67.5. What is the ratio of the SF6 emissions (in thousand metric tons of CO2 equivalent) in 2000 in Portugal to that in Romania?
Your answer should be compact. 64. What is the ratio of the SF6 emissions (in thousand metric tons of CO2 equivalent) of 2005 in Portugal to that in Romania?
Your answer should be compact. 47.18. What is the ratio of the SF6 emissions (in thousand metric tons of CO2 equivalent) in 2008 in Portugal to that in Romania?
Offer a terse response. 57.57. What is the ratio of the SF6 emissions (in thousand metric tons of CO2 equivalent) of 1990 in Portugal to that in Russian Federation?
Give a very brief answer. 0.02. What is the ratio of the SF6 emissions (in thousand metric tons of CO2 equivalent) in 2000 in Portugal to that in Russian Federation?
Provide a short and direct response. 0.01. What is the ratio of the SF6 emissions (in thousand metric tons of CO2 equivalent) of 2005 in Portugal to that in Russian Federation?
Make the answer very short. 0.01. What is the ratio of the SF6 emissions (in thousand metric tons of CO2 equivalent) in 2008 in Portugal to that in Russian Federation?
Your answer should be very brief. 0.01. What is the ratio of the SF6 emissions (in thousand metric tons of CO2 equivalent) in 2005 in Romania to that in Russian Federation?
Offer a very short reply. 0. What is the difference between the highest and the second highest SF6 emissions (in thousand metric tons of CO2 equivalent) of 1990?
Make the answer very short. 3877.8. What is the difference between the highest and the second highest SF6 emissions (in thousand metric tons of CO2 equivalent) in 2000?
Provide a succinct answer. 8686. What is the difference between the highest and the second highest SF6 emissions (in thousand metric tons of CO2 equivalent) in 2005?
Give a very brief answer. 8470.5. What is the difference between the highest and the second highest SF6 emissions (in thousand metric tons of CO2 equivalent) of 2008?
Offer a very short reply. 8496.6. What is the difference between the highest and the lowest SF6 emissions (in thousand metric tons of CO2 equivalent) of 1990?
Your answer should be very brief. 4885.2. What is the difference between the highest and the lowest SF6 emissions (in thousand metric tons of CO2 equivalent) in 2000?
Offer a terse response. 9031.2. What is the difference between the highest and the lowest SF6 emissions (in thousand metric tons of CO2 equivalent) in 2005?
Your response must be concise. 9287.7. What is the difference between the highest and the lowest SF6 emissions (in thousand metric tons of CO2 equivalent) in 2008?
Ensure brevity in your answer.  9445.9. 